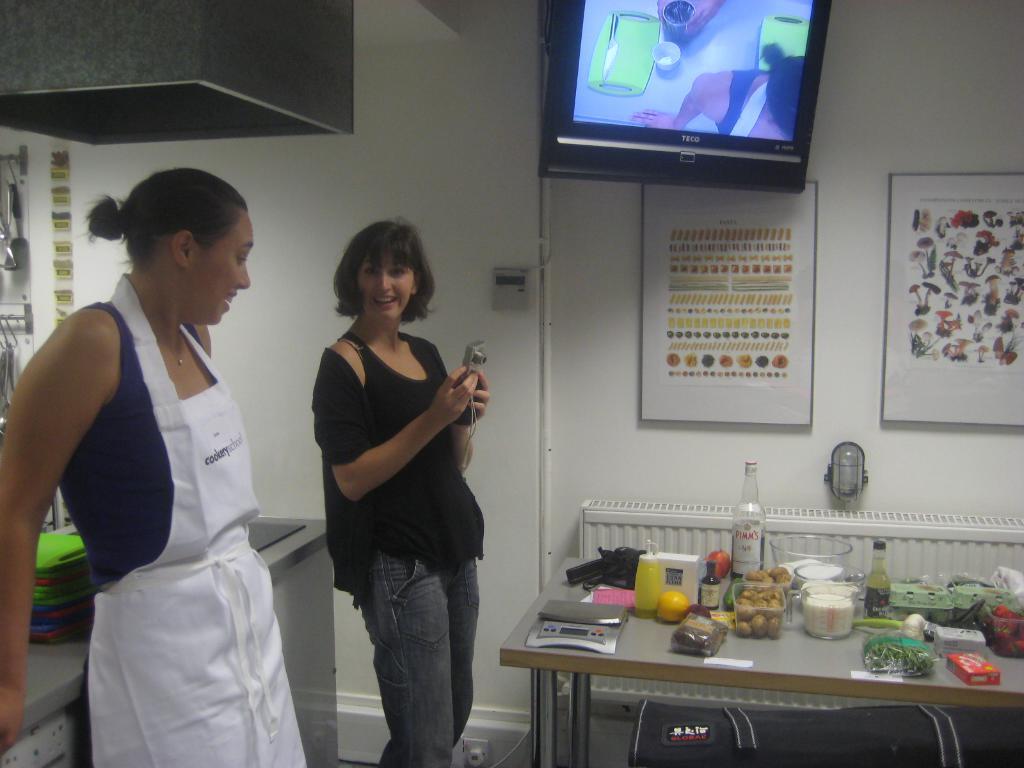Does this shop sell cigarettes?
Your answer should be very brief. Answering does not require reading text in the image. What is the name in red on the bottle?
Keep it short and to the point. Pimm's. 